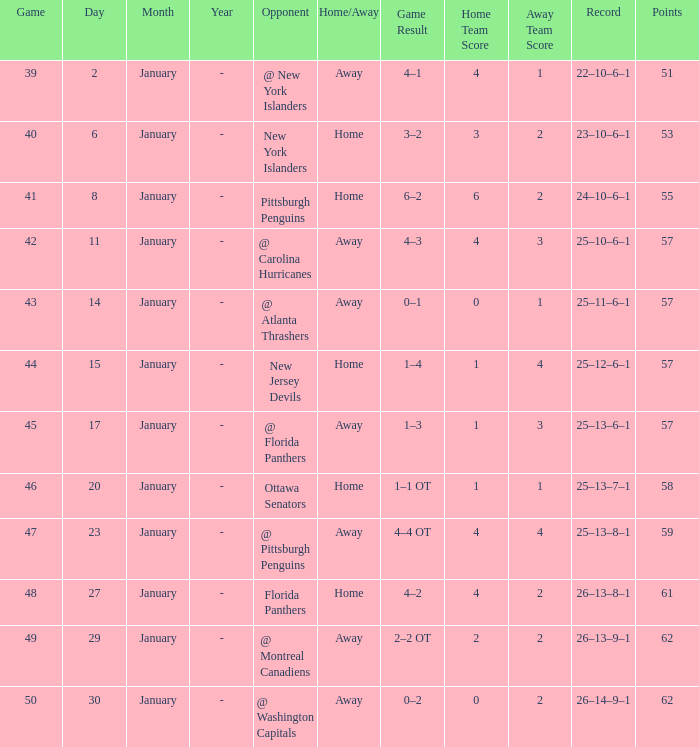Which adversary has a mean under 62 and a january mean less than 6? @ New York Islanders. 